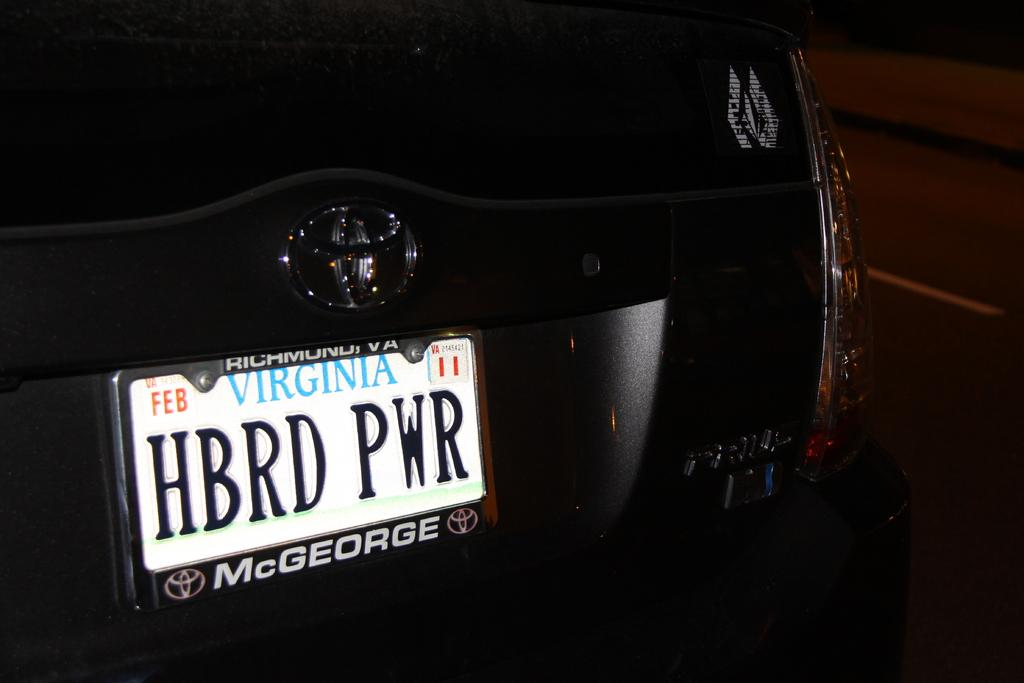<image>
Summarize the visual content of the image. Black Toyota Vehicle with Virginia Number plate says short form of Hybrid Power. 